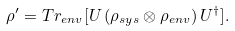<formula> <loc_0><loc_0><loc_500><loc_500>\rho ^ { \prime } = T r _ { e n v } [ U \, ( \rho _ { s y s } \otimes \rho _ { e n v } ) \, U ^ { \dag } ] .</formula> 